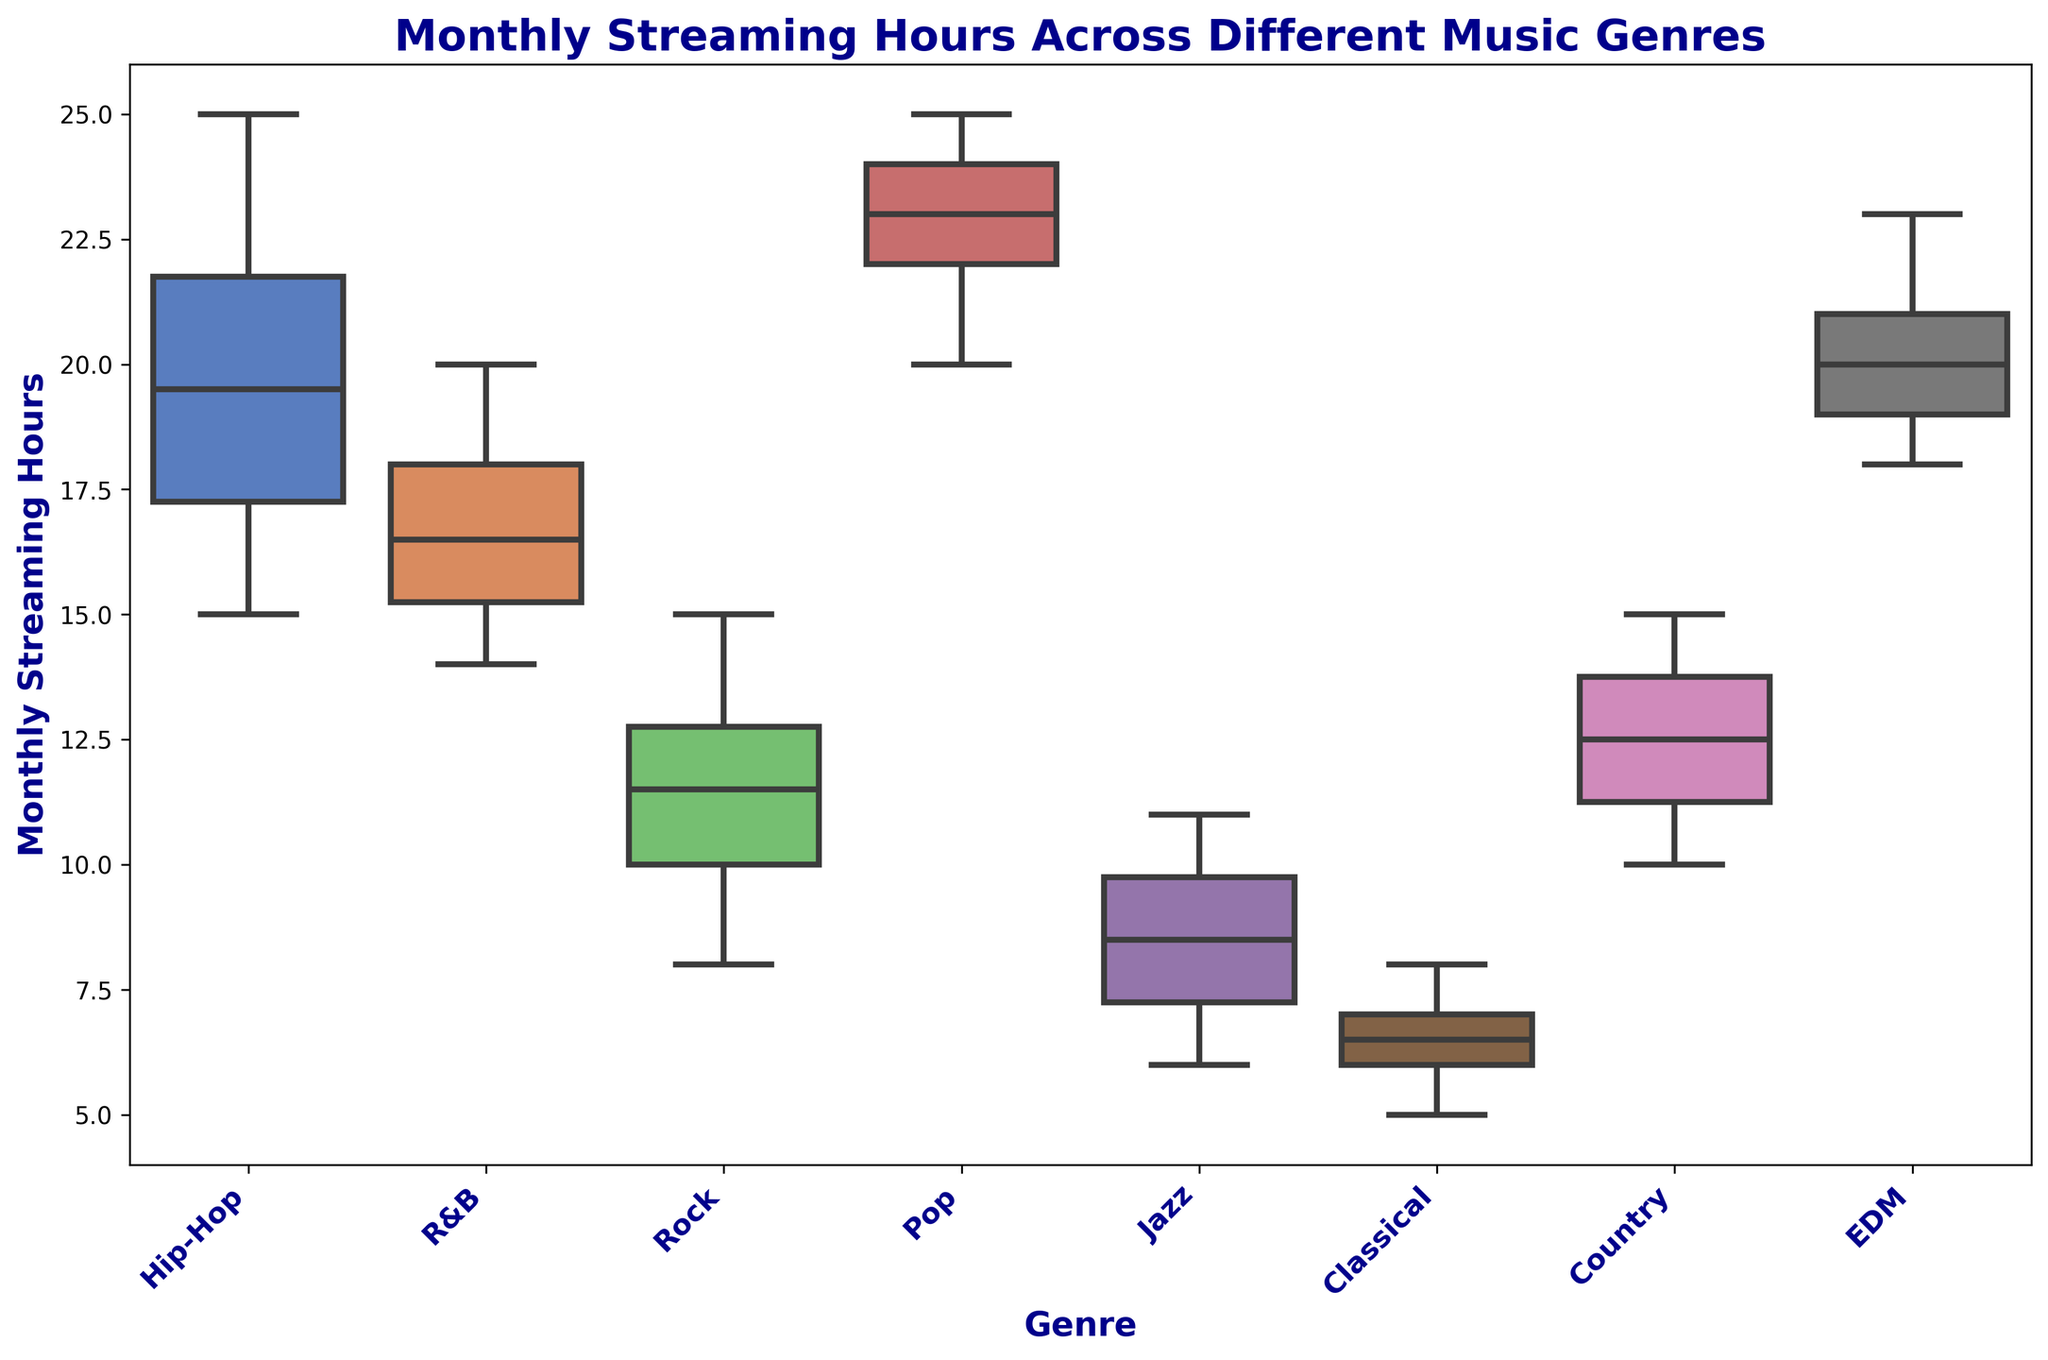What's the median monthly streaming hours for Hip-Hop? To find the median, we need to identify the middle value once the data is arranged in ascending order. For Hip-Hop: [15, 16, 17, 18, 19, 20, 21, 22, 23, 25], the median value is the average of the 5th and 6th values (19 and 20), so (19 + 20) / 2 = 19.5
Answer: 19.5 Which genre has the highest median monthly streaming hours? To determine the genre with the highest median, we need to compare the individual medians of each genre. The genre with the highest numerical median value will be the answer. Comparing the medians, Pop has the highest because its median is above the others.
Answer: Pop How do the maximum monthly streaming hours of EDM and Jazz compare? To compare the maximum values, look at the top point of the whiskers for both genres. For EDM, the maximum is 23, and for Jazz, it is 11. Clearly, EDM has a higher maximum value than Jazz.
Answer: EDM What is the range of monthly streaming hours for Classical music? The range is found by subtracting the minimum value from the maximum. For Classical, the minimum is 5 and the maximum is 8, so the range is 8 - 5 = 3.
Answer: 3 Which genre shows the greatest variability in monthly streaming hours? Variability can be estimated by looking at the length of the boxes and whiskers. The genre with the longest overall spread is Hip-Hop, as it has a wider box and longer whiskers compared to others.
Answer: Hip-Hop Are there any genres with the same median monthly streaming hours? To answer this, we need to identify the medians for each genre and compare them. In this case, both Hip-Hop and EDM have medians of 19.
Answer: Hip-Hop and EDM What's the interquartile range (IQR) for R&B? The IQR is calculated by finding the difference between the 75th percentile (upper quartile) and the 25th percentile (lower quartile). For R&B, the 25th percentile is 15.5 and the 75th percentile is 18. The IQR is 18 - 15.5 = 2.5.
Answer: 2.5 Which genre has the lowest median monthly streaming hours? By identifying the median values of each genre and comparing them, Classical music has the lowest median value.
Answer: Classical Does any genre have no outliers present in the data? By examining the plot for points outside the whiskers (which represent outliers), we see that all genres do not have individual points significantly distant from the whiskers.
Answer: No genres have significant outliers How does the median monthly streaming hours of Rock compare to the median of Jazz? Comparing the medians of both genres directly, Rock's median is 11 and Jazz's median is 8. Hence, Rock has a higher median than Jazz.
Answer: Rock 